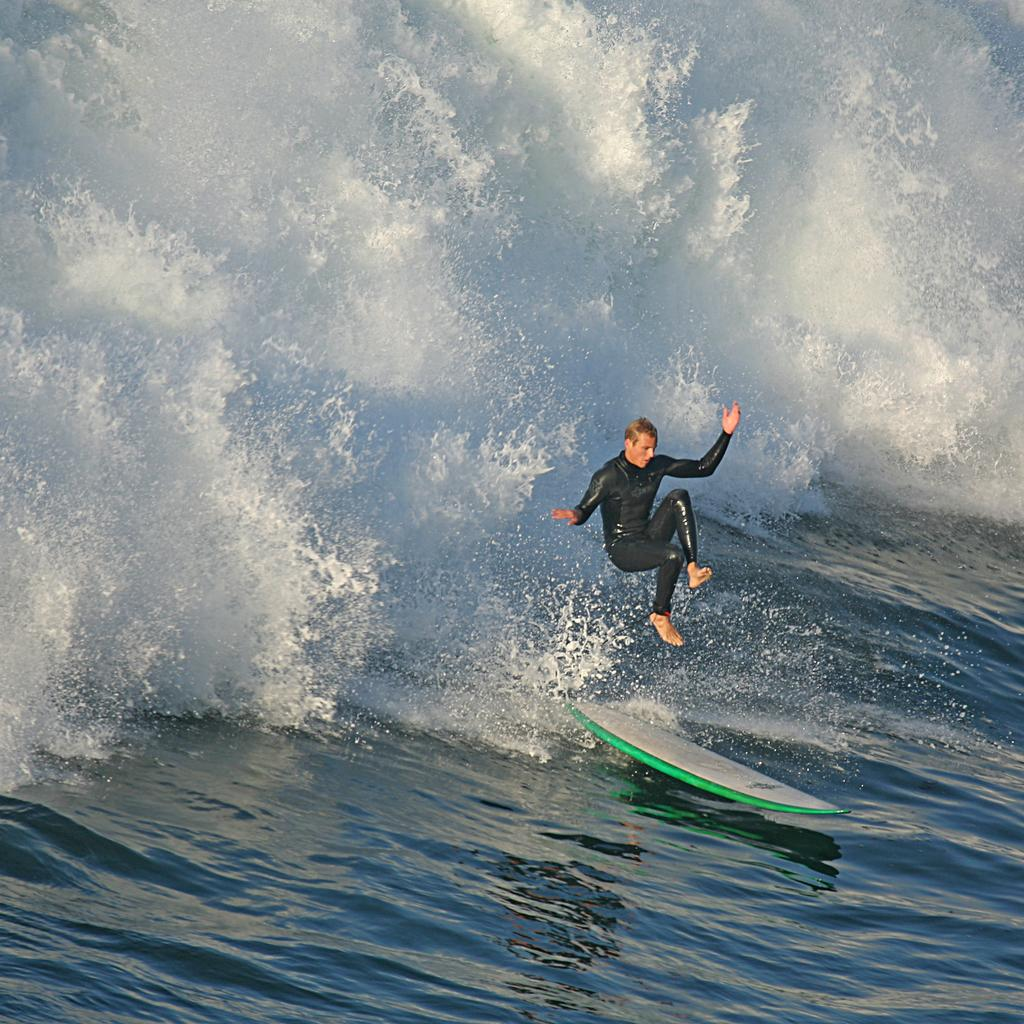What object is visible in the image that is used for riding waves? There is a surfboard in the image. Where is the surfboard located in the image? The surfboard is on the water. What is the man in the image doing? The man is in the air in the image. What type of punishment is the man receiving in the image? There is no indication of punishment in the image; the man is simply in the air. How many clocks are visible in the image? There are no clocks present in the image. 